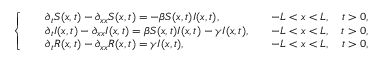<formula> <loc_0><loc_0><loc_500><loc_500>\left \{ \begin{array} { l l } { \begin{array} { r l r } & { \partial _ { t } S ( x , t ) - \partial _ { x x } S ( x , t ) = - \beta S ( x , t ) I ( x , t ) , } & { \quad - L < x < L , \quad t > 0 , } \\ & { \partial _ { t } I ( x , t ) - \partial _ { x x } I ( x , t ) = \beta S ( x , t ) I ( x , t ) - \gamma I ( x , t ) , } & { \quad - L < x < L , \quad t > 0 , } \\ & { \partial _ { t } R ( x , t ) - \partial _ { x x } R ( x , t ) = \gamma I ( x , t ) , } & { \quad - L < x < L , \quad t > 0 , } \end{array} } \end{array}</formula> 